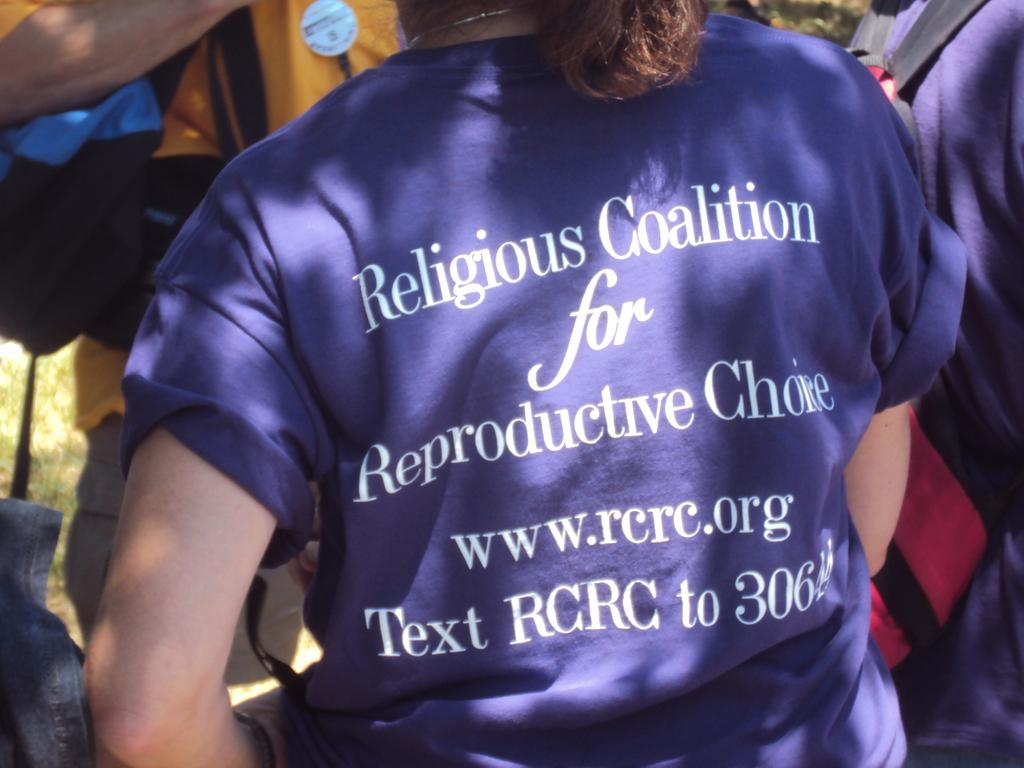Provide a one-sentence caption for the provided image. A girl wearing a purple shirt that says Religious Coalition for Reproductive Choice. 